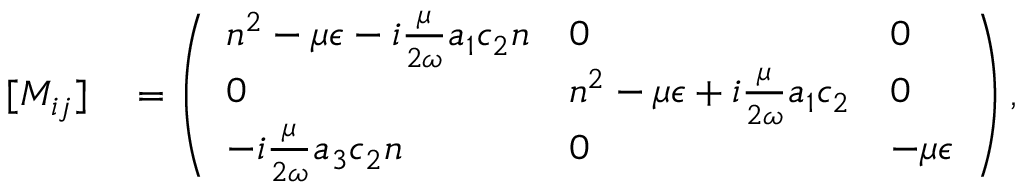Convert formula to latex. <formula><loc_0><loc_0><loc_500><loc_500>\begin{array} { r l } { [ M _ { i j } ] } & = \left ( \begin{array} { l l l } { n ^ { 2 } - \mu { \epsilon } - i \frac { \mu } { 2 \omega } a _ { 1 } c _ { 2 } n } & { 0 } & { 0 } \\ { 0 } & { n ^ { 2 } - \mu { \epsilon } + i \frac { \mu } { 2 \omega } a _ { 1 } c _ { 2 } } & { 0 } \\ { - i \frac { \mu } { 2 \omega } a _ { 3 } c _ { 2 } n } & { 0 } & { - \mu { \epsilon } } \end{array} \right ) , } \end{array}</formula> 